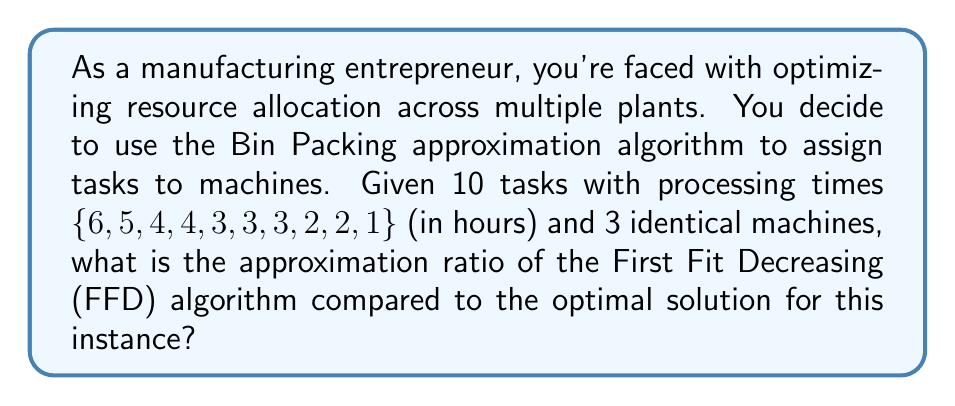Give your solution to this math problem. Let's approach this step-by-step:

1) First, sort the tasks in decreasing order:
   {6, 5, 4, 4, 3, 3, 3, 2, 2, 1}

2) Apply the First Fit Decreasing (FFD) algorithm:
   Machine 1: 6, 3, 2, 1 (total: 12 hours)
   Machine 2: 5, 4, 3 (total: 12 hours)
   Machine 3: 4, 3, 2 (total: 9 hours)

3) The makespan (completion time) of the FFD solution is 12 hours.

4) To find the optimal solution, we need to calculate the lower bound:
   
   Total processing time: $\sum_{i=1}^{n} p_i = 33$ hours
   Number of machines: $m = 3$
   
   Lower bound: $LB = \max(\lceil\frac{\sum_{i=1}^{n} p_i}{m}\rceil, p_{max}) = \max(\lceil\frac{33}{3}\rceil, 6) = 11$ hours

5) The optimal solution cannot be better than this lower bound. In this case, we can achieve this lower bound:
   Machine 1: 6, 5 (total: 11 hours)
   Machine 2: 4, 4, 3 (total: 11 hours)
   Machine 3: 3, 3, 2, 2, 1 (total: 11 hours)

6) The approximation ratio is calculated as:
   $\text{Approximation Ratio} = \frac{\text{FFD Solution}}{\text{Optimal Solution}} = \frac{12}{11}$

Therefore, for this specific instance, the approximation ratio of the FFD algorithm is $\frac{12}{11}$ or approximately 1.0909.

Note: While this example shows a ratio of $\frac{12}{11}$, the general worst-case approximation ratio for FFD in bin packing (and by extension, makespan minimization) is $\frac{11}{9} \approx 1.22$.
Answer: The approximation ratio of the First Fit Decreasing (FFD) algorithm compared to the optimal solution for this instance is $\frac{12}{11}$ or approximately 1.0909. 